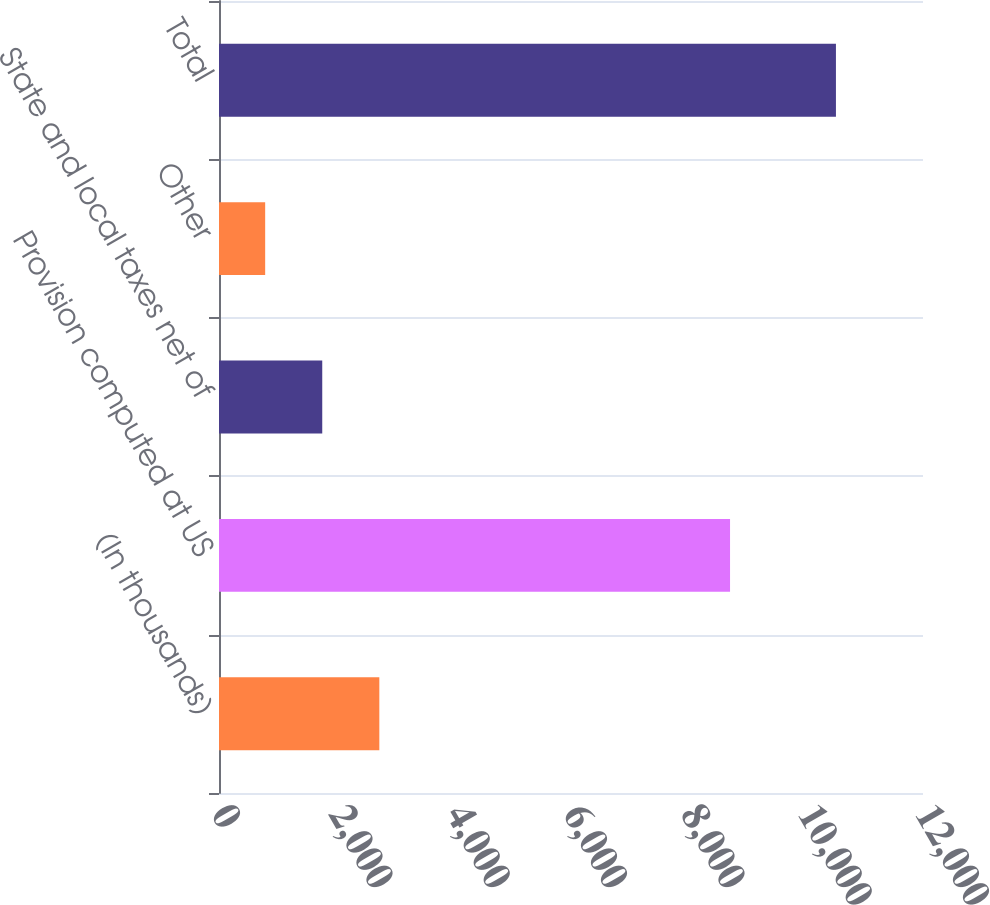<chart> <loc_0><loc_0><loc_500><loc_500><bar_chart><fcel>(In thousands)<fcel>Provision computed at US<fcel>State and local taxes net of<fcel>Other<fcel>Total<nl><fcel>2732.8<fcel>8711<fcel>1759.9<fcel>787<fcel>10516<nl></chart> 